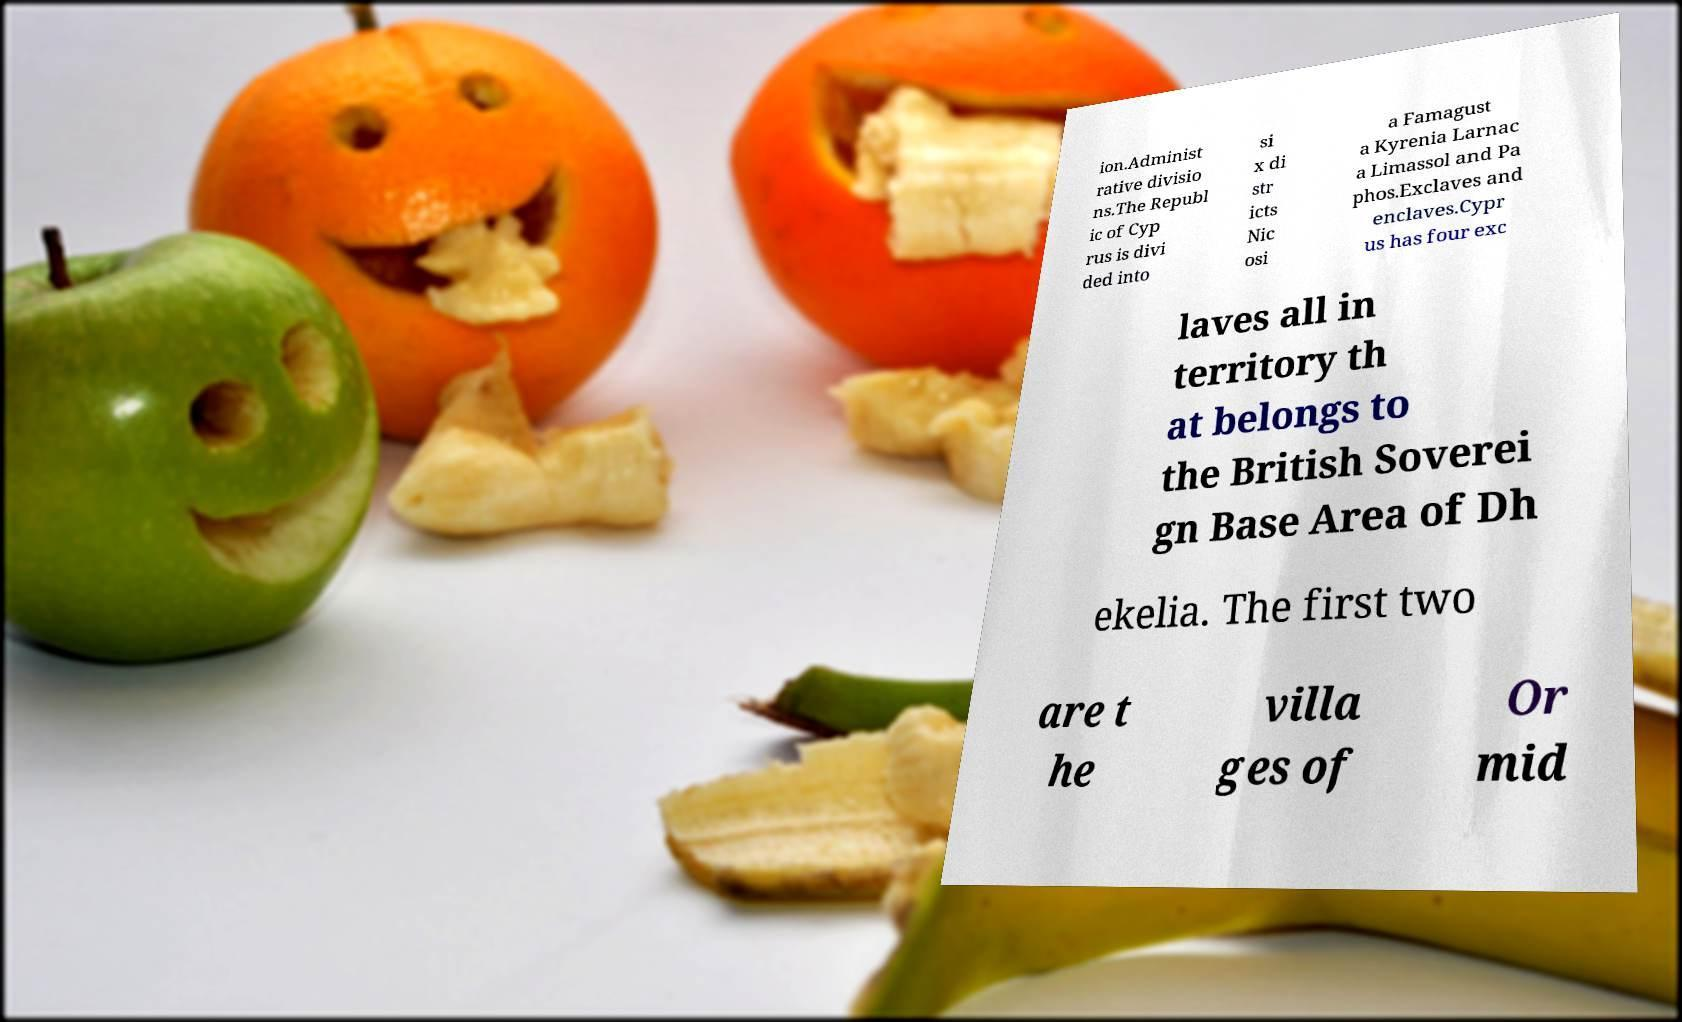Could you extract and type out the text from this image? ion.Administ rative divisio ns.The Republ ic of Cyp rus is divi ded into si x di str icts Nic osi a Famagust a Kyrenia Larnac a Limassol and Pa phos.Exclaves and enclaves.Cypr us has four exc laves all in territory th at belongs to the British Soverei gn Base Area of Dh ekelia. The first two are t he villa ges of Or mid 